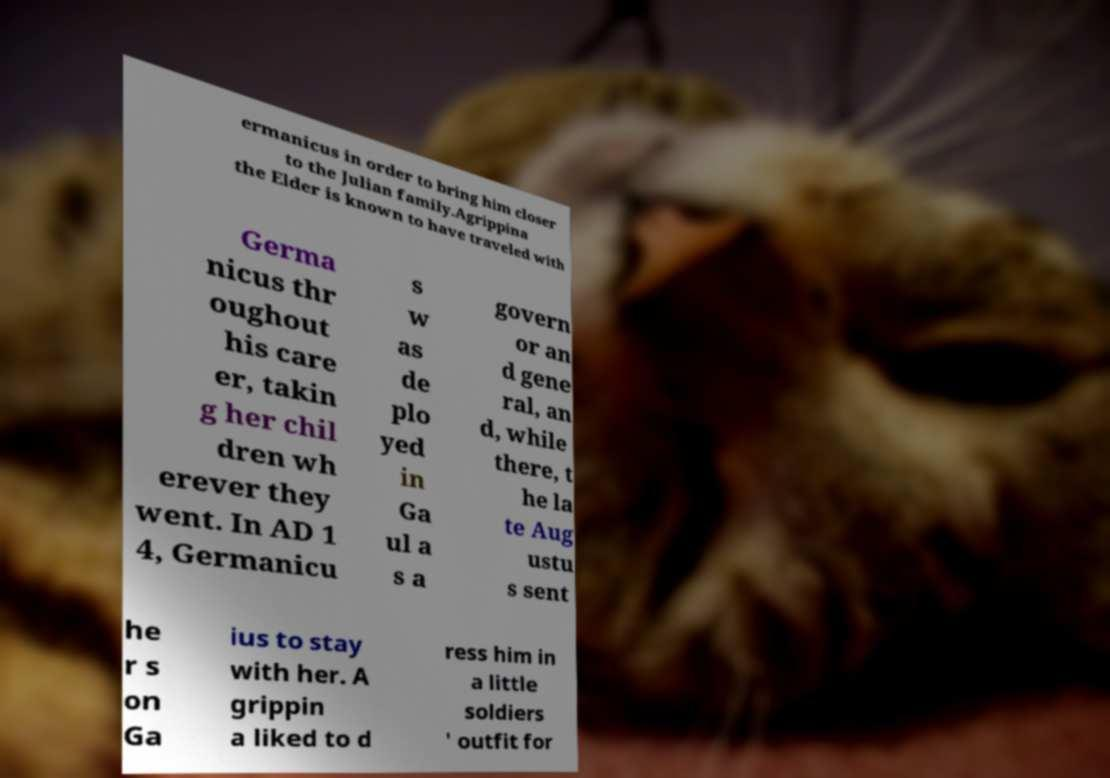Can you accurately transcribe the text from the provided image for me? ermanicus in order to bring him closer to the Julian family.Agrippina the Elder is known to have traveled with Germa nicus thr oughout his care er, takin g her chil dren wh erever they went. In AD 1 4, Germanicu s w as de plo yed in Ga ul a s a govern or an d gene ral, an d, while there, t he la te Aug ustu s sent he r s on Ga ius to stay with her. A grippin a liked to d ress him in a little soldiers ' outfit for 